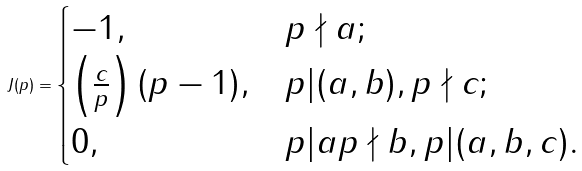<formula> <loc_0><loc_0><loc_500><loc_500>J ( p ) = \begin{cases} - 1 , & p \nmid a ; \\ \left ( \frac { c } { p } \right ) ( p - 1 ) , & p | ( a , b ) , p \nmid c ; \\ 0 , & p | a p \nmid b , p | ( a , b , c ) . \end{cases}</formula> 